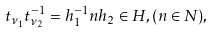<formula> <loc_0><loc_0><loc_500><loc_500>t _ { \nu _ { 1 } } t _ { \nu _ { 2 } } ^ { - 1 } = h _ { 1 } ^ { - 1 } n h _ { 2 } \in H , ( n \in N ) ,</formula> 